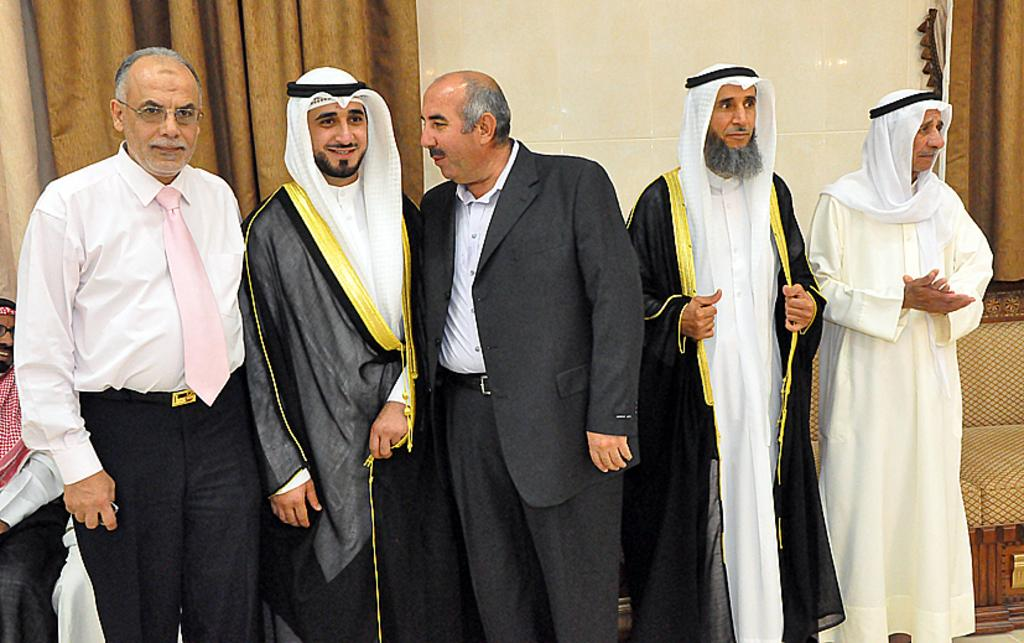What are the people in the image doing? The people in the image are standing. Can you describe the seating arrangement in the image? There is at least one person sitting in the image. What can be seen in the background of the image? There are curtains and a couch in the background of the image. Can you tell me how many airplanes are visible in the image? There are no airplanes visible in the image. What type of note is the person holding in the image? There is no person holding a note in the image. What type of bird can be seen perched on the couch in the image? There is no bird, specifically a wren, present in the image. 